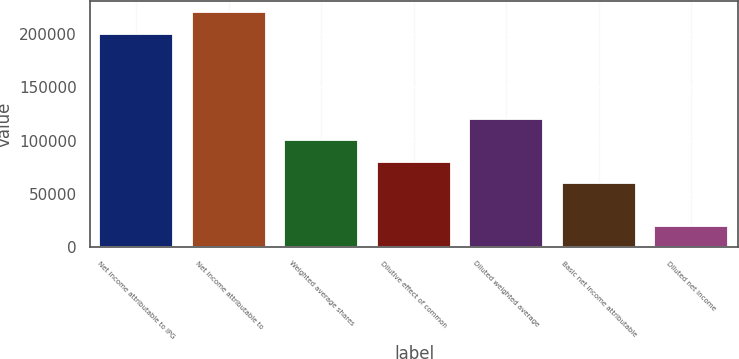Convert chart. <chart><loc_0><loc_0><loc_500><loc_500><bar_chart><fcel>Net income attributable to IPG<fcel>Net income attributable to<fcel>Weighted average shares<fcel>Dilutive effect of common<fcel>Diluted weighted average<fcel>Basic net income attributable<fcel>Diluted net income<nl><fcel>200445<fcel>220489<fcel>100224<fcel>80180.3<fcel>120269<fcel>60136.2<fcel>20047.9<nl></chart> 